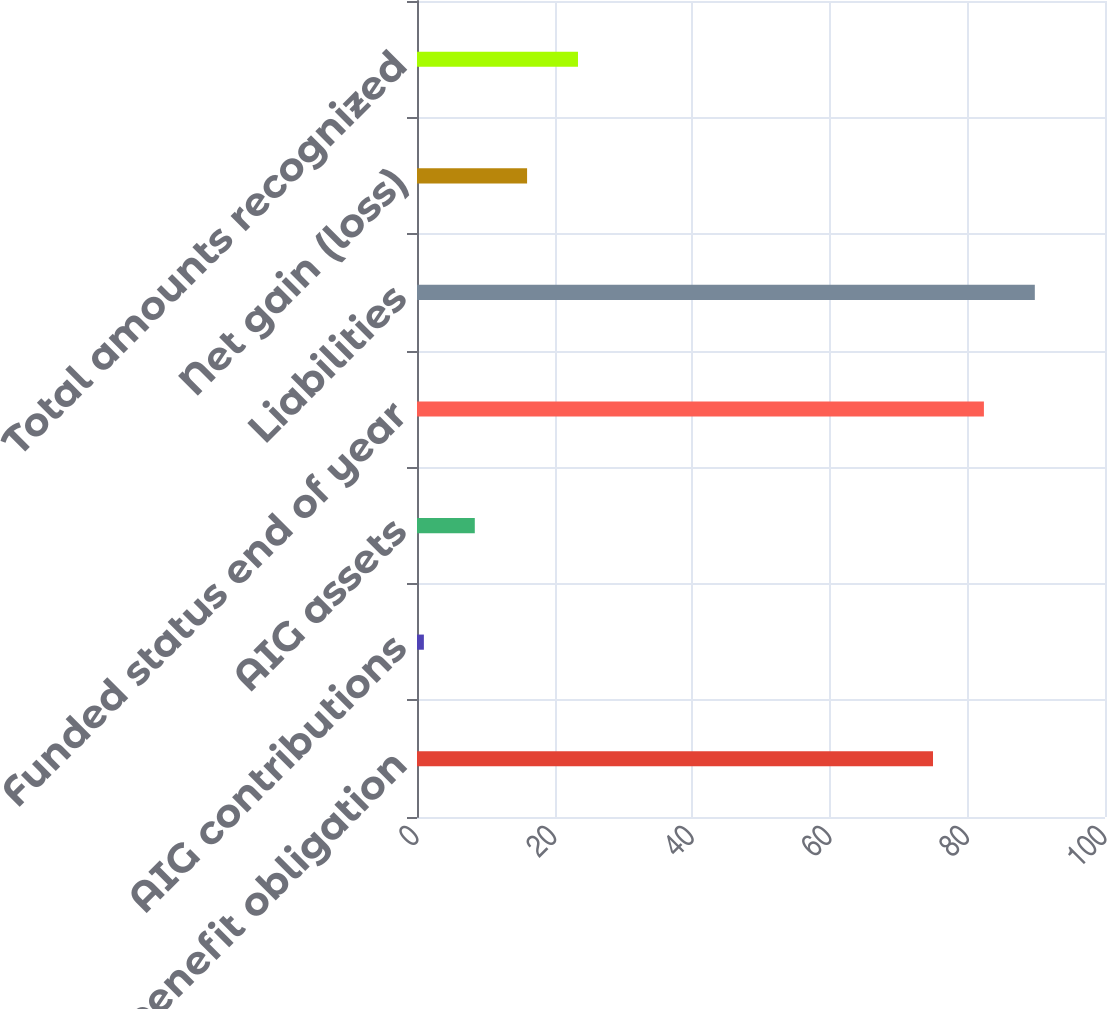Convert chart. <chart><loc_0><loc_0><loc_500><loc_500><bar_chart><fcel>Projected benefit obligation<fcel>AIG contributions<fcel>AIG assets<fcel>Funded status end of year<fcel>Liabilities<fcel>Net gain (loss)<fcel>Total amounts recognized<nl><fcel>75<fcel>1<fcel>8.4<fcel>82.4<fcel>89.8<fcel>16<fcel>23.4<nl></chart> 